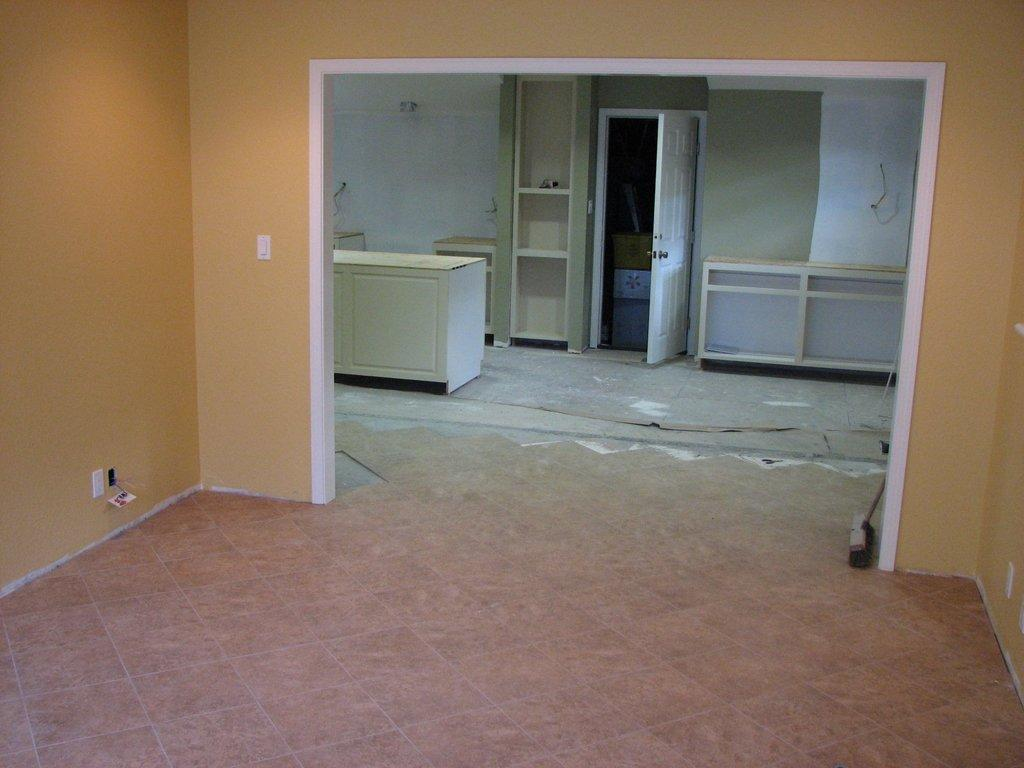How many rooms can be seen in the image? There are two rooms in the image. What type of furniture is present in the image? There are shelves and a cupboard in the image. Is there any entrance or exit visible in the image? Yes, there is a door in the image. What else can be seen in the image besides furniture? There are cardboard boxes in the image. What can be seen on the walls in the image? The walls are visible in the image. Can you tell me how many muscles are visible on the doll in the image? There is no doll present in the image, so it is not possible to determine the number of muscles visible. What type of badge is being worn by the person in the image? There is no person or badge present in the image. 